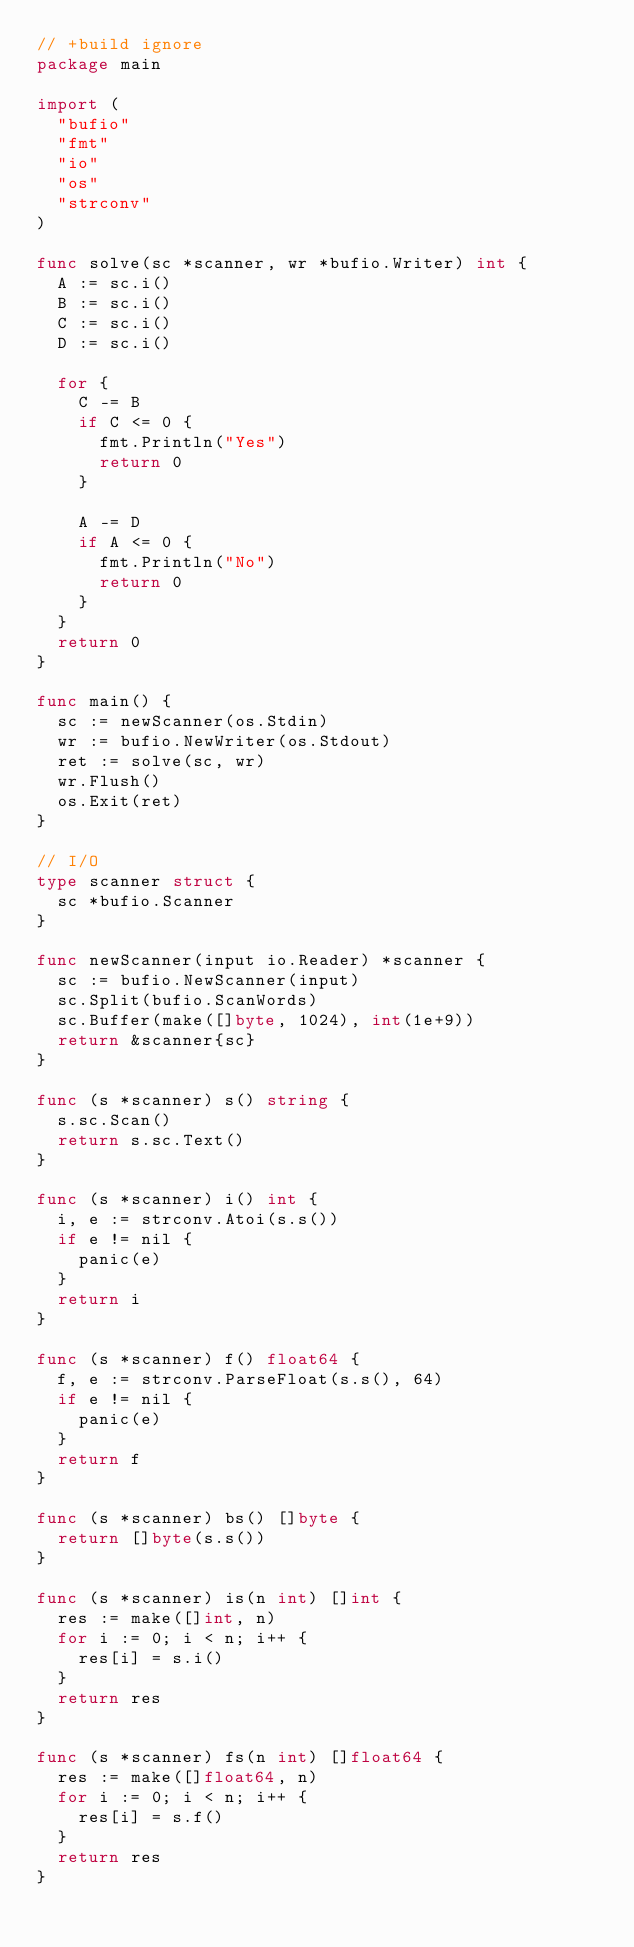Convert code to text. <code><loc_0><loc_0><loc_500><loc_500><_Go_>// +build ignore
package main

import (
	"bufio"
	"fmt"
	"io"
	"os"
	"strconv"
)

func solve(sc *scanner, wr *bufio.Writer) int {
	A := sc.i()
	B := sc.i()
	C := sc.i()
	D := sc.i()

	for {
		C -= B
		if C <= 0 {
			fmt.Println("Yes")
			return 0
		}

		A -= D
		if A <= 0 {
			fmt.Println("No")
			return 0
		}
	}
	return 0
}

func main() {
	sc := newScanner(os.Stdin)
	wr := bufio.NewWriter(os.Stdout)
	ret := solve(sc, wr)
	wr.Flush()
	os.Exit(ret)
}

// I/O
type scanner struct {
	sc *bufio.Scanner
}

func newScanner(input io.Reader) *scanner {
	sc := bufio.NewScanner(input)
	sc.Split(bufio.ScanWords)
	sc.Buffer(make([]byte, 1024), int(1e+9))
	return &scanner{sc}
}

func (s *scanner) s() string {
	s.sc.Scan()
	return s.sc.Text()
}

func (s *scanner) i() int {
	i, e := strconv.Atoi(s.s())
	if e != nil {
		panic(e)
	}
	return i
}

func (s *scanner) f() float64 {
	f, e := strconv.ParseFloat(s.s(), 64)
	if e != nil {
		panic(e)
	}
	return f
}

func (s *scanner) bs() []byte {
	return []byte(s.s())
}

func (s *scanner) is(n int) []int {
	res := make([]int, n)
	for i := 0; i < n; i++ {
		res[i] = s.i()
	}
	return res
}

func (s *scanner) fs(n int) []float64 {
	res := make([]float64, n)
	for i := 0; i < n; i++ {
		res[i] = s.f()
	}
	return res
}
</code> 